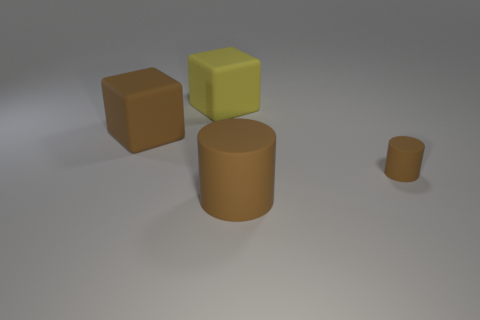There is a cylinder to the right of the matte cylinder that is in front of the small object; what color is it?
Your answer should be very brief. Brown. Do the large cylinder and the small thing to the right of the brown rubber block have the same color?
Offer a very short reply. Yes. There is a large yellow matte block on the left side of the large brown thing that is on the right side of the large yellow rubber thing; what number of yellow rubber cubes are left of it?
Your answer should be very brief. 0. There is a yellow object; are there any large matte cylinders in front of it?
Give a very brief answer. Yes. Is there any other thing that is the same color as the small rubber cylinder?
Offer a very short reply. Yes. What number of cubes are large things or tiny gray metal things?
Offer a very short reply. 2. What number of big brown things are left of the big brown matte cylinder and right of the large yellow object?
Give a very brief answer. 0. Are there an equal number of tiny brown things on the left side of the large brown matte cylinder and large rubber cylinders that are right of the big yellow object?
Keep it short and to the point. No. Is the shape of the brown thing behind the tiny object the same as  the small rubber thing?
Your answer should be compact. No. What is the shape of the large matte thing that is in front of the brown rubber thing that is right of the brown cylinder in front of the small brown object?
Your response must be concise. Cylinder. 